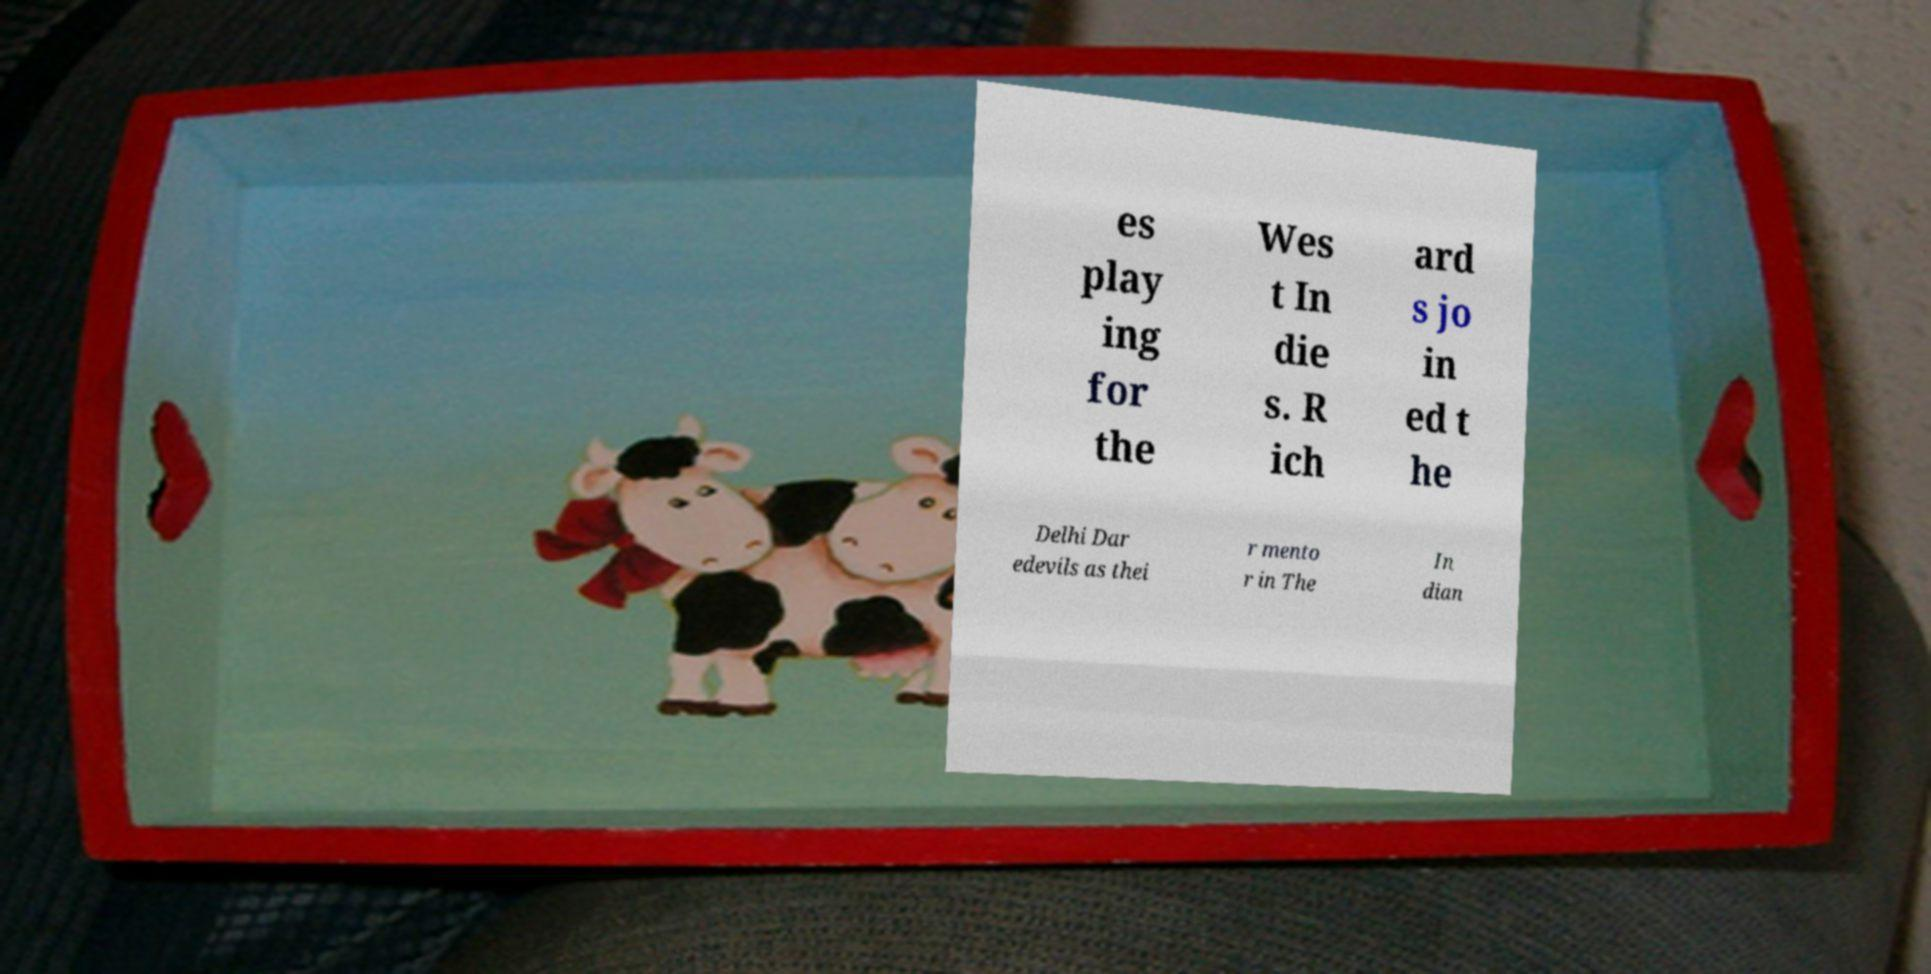Could you assist in decoding the text presented in this image and type it out clearly? es play ing for the Wes t In die s. R ich ard s jo in ed t he Delhi Dar edevils as thei r mento r in The In dian 